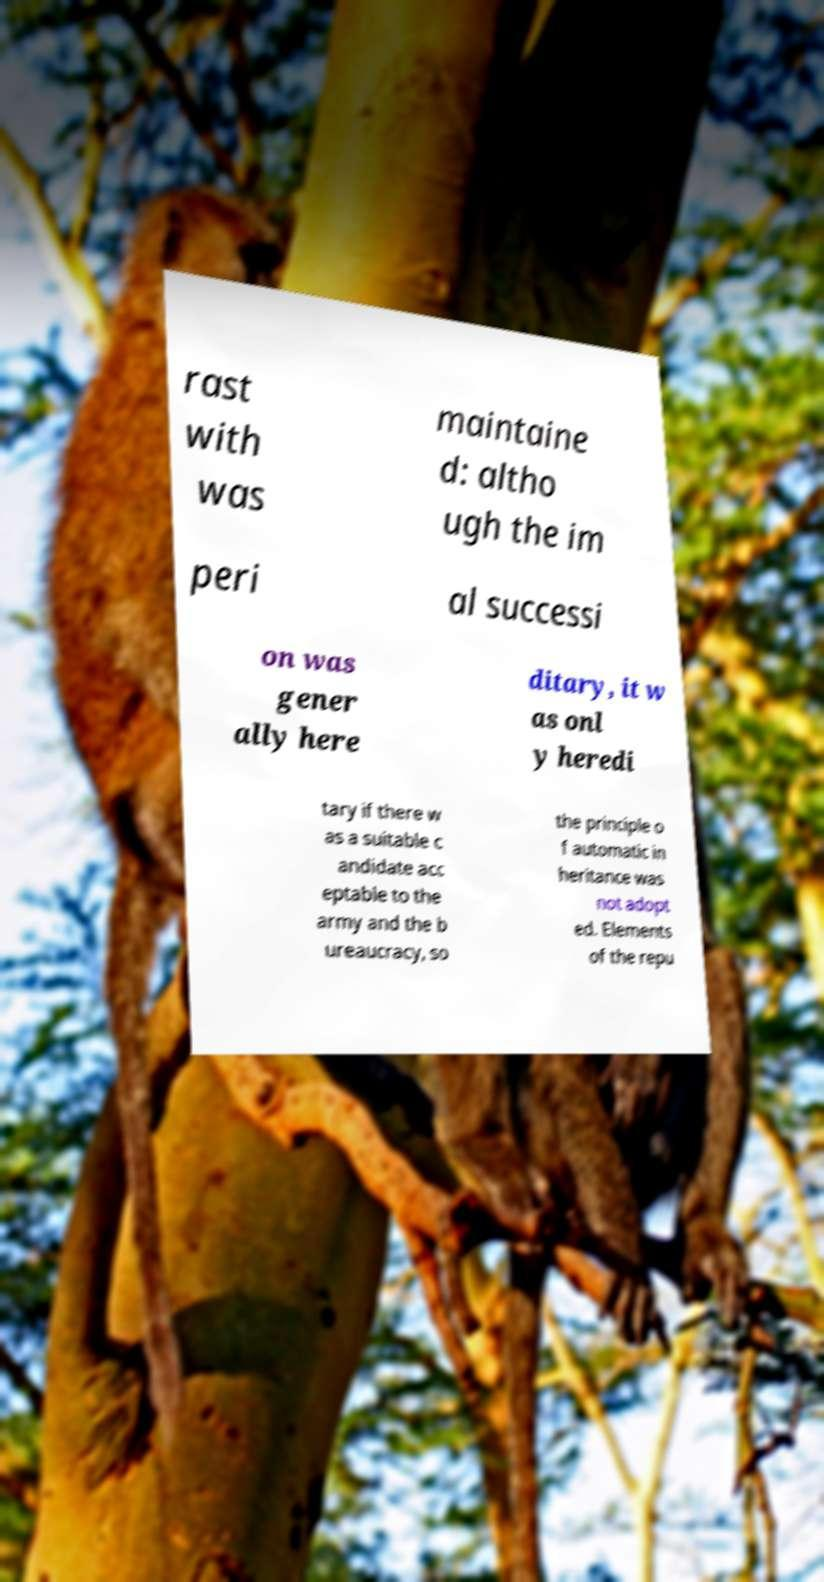There's text embedded in this image that I need extracted. Can you transcribe it verbatim? rast with was maintaine d: altho ugh the im peri al successi on was gener ally here ditary, it w as onl y heredi tary if there w as a suitable c andidate acc eptable to the army and the b ureaucracy, so the principle o f automatic in heritance was not adopt ed. Elements of the repu 